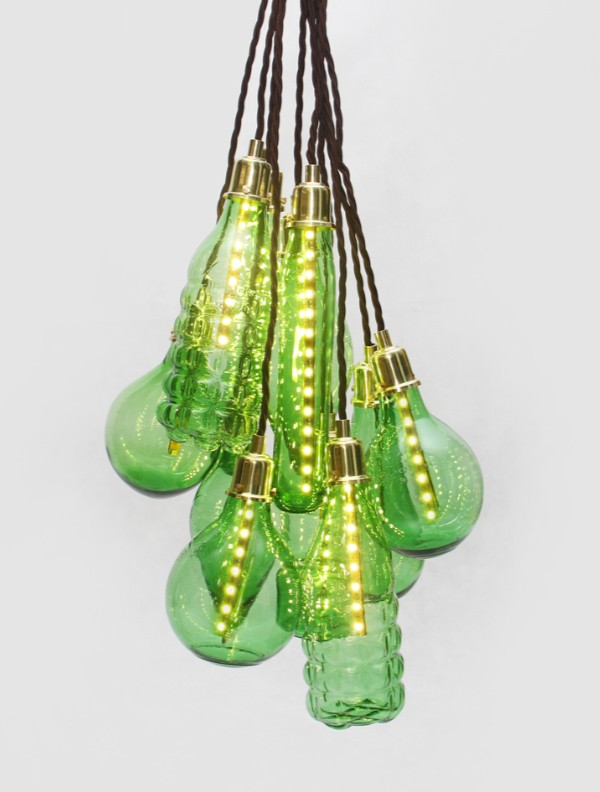Imagine these light fixtures were designed by an ancient artisan using mystical techniques. What story would their creation tell? In a time long forgotten, nestled within the heart of an enchanted forest, an ancient artisan named Elara discovered a hidden fount of mystical energy. She was known throughout the lands for her unparalleled skill in crafting light from glass, infused with the life force of nature itself. Each evening, as the forest danced with twilight hues, Elara collected dew drops that shimmered with the magic of the moon. Combining these enchanted droplets with her extraordinary craftsmanship, she created light fixtures that radiated with an ethereal glow, capable of warding off darkness and bringing tranquility to all who basked in their light. The shapes, reminiscent of fruits and flowers, were not mere designs but living relics of the forest's spirit, frozen in time to guard their luminous essence. These fixtures, legends told, were imbued with the power to heal and inspire, casting a warmth that reflected the nurturing embrace of Mother Earth herself. How might these mystical light fixtures adapt to the needs of a modern household while retaining their enchantment? In a modern household, these mystical light fixtures could seamlessly blend ancient enchantment with contemporary functionality. Retaining their original charm, the fixtures would adapt with subtle, magical whispers—automatically dimming or brightening based on the household's needs. During the day, the lights would absorb and store ambient energy, glowing gently in the evenings to create a serene atmosphere. Perhaps they would sync with the rhythms of the household, softly pulsing in time with joyful moments or glowing vibrantly during gatherings. As they adjust, they would continue casting their mystical charm, fostering a sense of peace and well-being. Hidden within each fixture, tiny enchanted symbols would pulse with light, subtly communicating the mood of the home, blending a touch of antiquity with the convenience of modern smart lighting technology. 